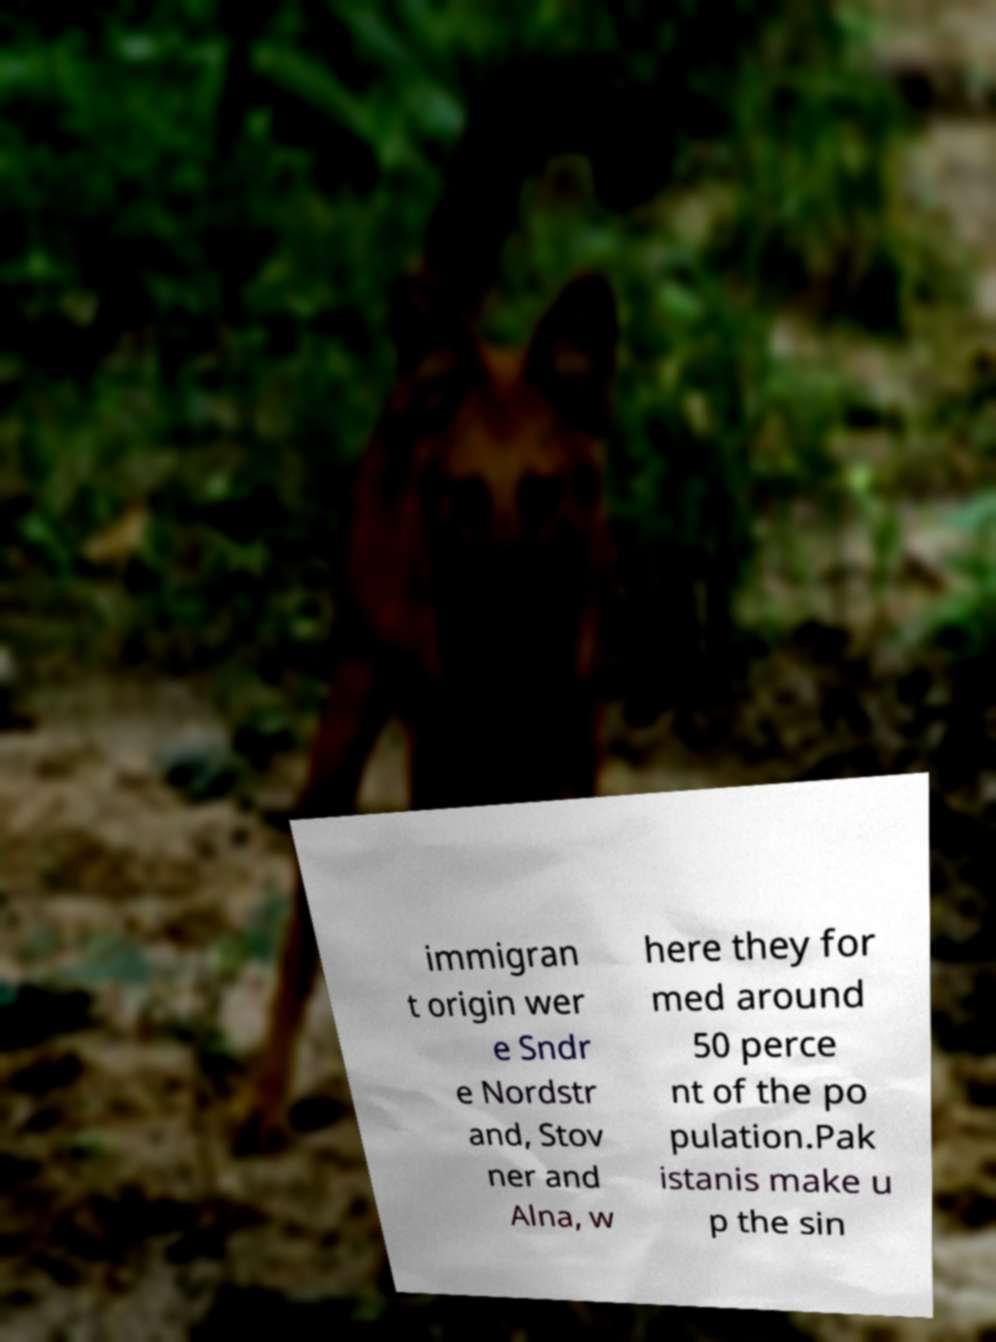Could you assist in decoding the text presented in this image and type it out clearly? immigran t origin wer e Sndr e Nordstr and, Stov ner and Alna, w here they for med around 50 perce nt of the po pulation.Pak istanis make u p the sin 